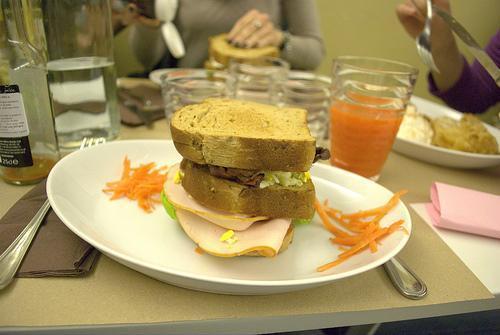How many sandwiches are on the plate?
Give a very brief answer. 1. 